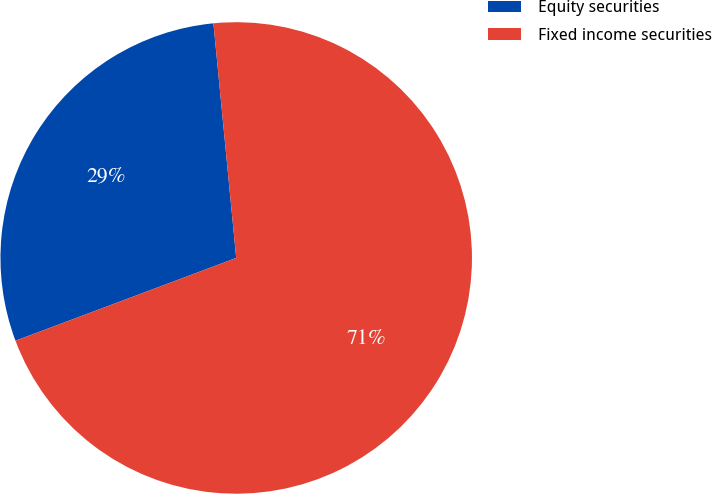<chart> <loc_0><loc_0><loc_500><loc_500><pie_chart><fcel>Equity securities<fcel>Fixed income securities<nl><fcel>29.17%<fcel>70.83%<nl></chart> 